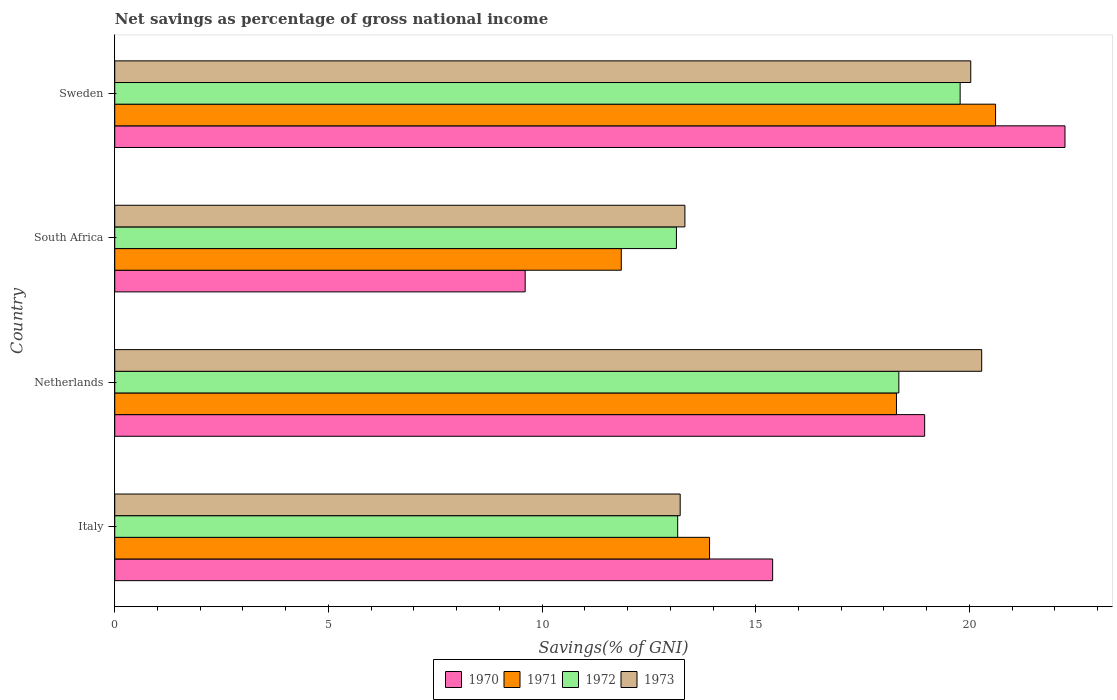How many different coloured bars are there?
Offer a very short reply. 4. Are the number of bars per tick equal to the number of legend labels?
Give a very brief answer. Yes. Are the number of bars on each tick of the Y-axis equal?
Offer a very short reply. Yes. How many bars are there on the 4th tick from the top?
Offer a terse response. 4. In how many cases, is the number of bars for a given country not equal to the number of legend labels?
Provide a short and direct response. 0. What is the total savings in 1972 in Netherlands?
Offer a terse response. 18.35. Across all countries, what is the maximum total savings in 1972?
Your answer should be very brief. 19.78. Across all countries, what is the minimum total savings in 1971?
Provide a succinct answer. 11.85. In which country was the total savings in 1973 maximum?
Make the answer very short. Netherlands. In which country was the total savings in 1973 minimum?
Ensure brevity in your answer.  Italy. What is the total total savings in 1971 in the graph?
Make the answer very short. 64.68. What is the difference between the total savings in 1973 in Netherlands and that in Sweden?
Offer a very short reply. 0.26. What is the difference between the total savings in 1970 in Italy and the total savings in 1971 in Sweden?
Offer a terse response. -5.22. What is the average total savings in 1972 per country?
Provide a succinct answer. 16.11. What is the difference between the total savings in 1971 and total savings in 1973 in Italy?
Offer a very short reply. 0.69. In how many countries, is the total savings in 1973 greater than 10 %?
Your response must be concise. 4. What is the ratio of the total savings in 1973 in Netherlands to that in South Africa?
Offer a very short reply. 1.52. Is the total savings in 1970 in Netherlands less than that in South Africa?
Make the answer very short. No. Is the difference between the total savings in 1971 in Netherlands and South Africa greater than the difference between the total savings in 1973 in Netherlands and South Africa?
Offer a very short reply. No. What is the difference between the highest and the second highest total savings in 1971?
Provide a succinct answer. 2.32. What is the difference between the highest and the lowest total savings in 1973?
Your response must be concise. 7.06. What does the 3rd bar from the bottom in Italy represents?
Keep it short and to the point. 1972. Are all the bars in the graph horizontal?
Provide a short and direct response. Yes. What is the difference between two consecutive major ticks on the X-axis?
Ensure brevity in your answer.  5. Are the values on the major ticks of X-axis written in scientific E-notation?
Your answer should be compact. No. Does the graph contain grids?
Provide a succinct answer. No. Where does the legend appear in the graph?
Your response must be concise. Bottom center. How many legend labels are there?
Give a very brief answer. 4. What is the title of the graph?
Your answer should be compact. Net savings as percentage of gross national income. Does "2011" appear as one of the legend labels in the graph?
Give a very brief answer. No. What is the label or title of the X-axis?
Give a very brief answer. Savings(% of GNI). What is the label or title of the Y-axis?
Your answer should be very brief. Country. What is the Savings(% of GNI) in 1970 in Italy?
Keep it short and to the point. 15.4. What is the Savings(% of GNI) in 1971 in Italy?
Offer a terse response. 13.92. What is the Savings(% of GNI) in 1972 in Italy?
Give a very brief answer. 13.17. What is the Savings(% of GNI) of 1973 in Italy?
Your answer should be compact. 13.23. What is the Savings(% of GNI) in 1970 in Netherlands?
Offer a very short reply. 18.95. What is the Savings(% of GNI) in 1971 in Netherlands?
Provide a succinct answer. 18.29. What is the Savings(% of GNI) of 1972 in Netherlands?
Ensure brevity in your answer.  18.35. What is the Savings(% of GNI) in 1973 in Netherlands?
Ensure brevity in your answer.  20.29. What is the Savings(% of GNI) of 1970 in South Africa?
Your answer should be very brief. 9.6. What is the Savings(% of GNI) in 1971 in South Africa?
Your answer should be compact. 11.85. What is the Savings(% of GNI) in 1972 in South Africa?
Give a very brief answer. 13.14. What is the Savings(% of GNI) in 1973 in South Africa?
Give a very brief answer. 13.34. What is the Savings(% of GNI) in 1970 in Sweden?
Your answer should be very brief. 22.24. What is the Savings(% of GNI) in 1971 in Sweden?
Your answer should be compact. 20.61. What is the Savings(% of GNI) of 1972 in Sweden?
Your answer should be very brief. 19.78. What is the Savings(% of GNI) of 1973 in Sweden?
Make the answer very short. 20.03. Across all countries, what is the maximum Savings(% of GNI) of 1970?
Your answer should be compact. 22.24. Across all countries, what is the maximum Savings(% of GNI) of 1971?
Ensure brevity in your answer.  20.61. Across all countries, what is the maximum Savings(% of GNI) in 1972?
Your answer should be compact. 19.78. Across all countries, what is the maximum Savings(% of GNI) in 1973?
Your answer should be very brief. 20.29. Across all countries, what is the minimum Savings(% of GNI) of 1970?
Offer a very short reply. 9.6. Across all countries, what is the minimum Savings(% of GNI) of 1971?
Offer a very short reply. 11.85. Across all countries, what is the minimum Savings(% of GNI) of 1972?
Offer a very short reply. 13.14. Across all countries, what is the minimum Savings(% of GNI) of 1973?
Provide a short and direct response. 13.23. What is the total Savings(% of GNI) in 1970 in the graph?
Your response must be concise. 66.19. What is the total Savings(% of GNI) in 1971 in the graph?
Give a very brief answer. 64.68. What is the total Savings(% of GNI) in 1972 in the graph?
Your answer should be very brief. 64.45. What is the total Savings(% of GNI) in 1973 in the graph?
Your answer should be compact. 66.89. What is the difference between the Savings(% of GNI) in 1970 in Italy and that in Netherlands?
Make the answer very short. -3.56. What is the difference between the Savings(% of GNI) in 1971 in Italy and that in Netherlands?
Your answer should be compact. -4.37. What is the difference between the Savings(% of GNI) in 1972 in Italy and that in Netherlands?
Provide a succinct answer. -5.18. What is the difference between the Savings(% of GNI) in 1973 in Italy and that in Netherlands?
Your answer should be very brief. -7.06. What is the difference between the Savings(% of GNI) in 1970 in Italy and that in South Africa?
Your answer should be very brief. 5.79. What is the difference between the Savings(% of GNI) in 1971 in Italy and that in South Africa?
Your answer should be compact. 2.07. What is the difference between the Savings(% of GNI) in 1972 in Italy and that in South Africa?
Provide a succinct answer. 0.03. What is the difference between the Savings(% of GNI) of 1973 in Italy and that in South Africa?
Your answer should be compact. -0.11. What is the difference between the Savings(% of GNI) of 1970 in Italy and that in Sweden?
Ensure brevity in your answer.  -6.84. What is the difference between the Savings(% of GNI) in 1971 in Italy and that in Sweden?
Make the answer very short. -6.69. What is the difference between the Savings(% of GNI) in 1972 in Italy and that in Sweden?
Make the answer very short. -6.61. What is the difference between the Savings(% of GNI) of 1973 in Italy and that in Sweden?
Your response must be concise. -6.8. What is the difference between the Savings(% of GNI) of 1970 in Netherlands and that in South Africa?
Provide a short and direct response. 9.35. What is the difference between the Savings(% of GNI) in 1971 in Netherlands and that in South Africa?
Give a very brief answer. 6.44. What is the difference between the Savings(% of GNI) in 1972 in Netherlands and that in South Africa?
Offer a very short reply. 5.21. What is the difference between the Savings(% of GNI) in 1973 in Netherlands and that in South Africa?
Ensure brevity in your answer.  6.95. What is the difference between the Savings(% of GNI) of 1970 in Netherlands and that in Sweden?
Your answer should be compact. -3.28. What is the difference between the Savings(% of GNI) in 1971 in Netherlands and that in Sweden?
Ensure brevity in your answer.  -2.32. What is the difference between the Savings(% of GNI) in 1972 in Netherlands and that in Sweden?
Keep it short and to the point. -1.43. What is the difference between the Savings(% of GNI) in 1973 in Netherlands and that in Sweden?
Provide a short and direct response. 0.26. What is the difference between the Savings(% of GNI) of 1970 in South Africa and that in Sweden?
Give a very brief answer. -12.63. What is the difference between the Savings(% of GNI) in 1971 in South Africa and that in Sweden?
Provide a succinct answer. -8.76. What is the difference between the Savings(% of GNI) in 1972 in South Africa and that in Sweden?
Offer a very short reply. -6.64. What is the difference between the Savings(% of GNI) of 1973 in South Africa and that in Sweden?
Give a very brief answer. -6.69. What is the difference between the Savings(% of GNI) of 1970 in Italy and the Savings(% of GNI) of 1971 in Netherlands?
Your response must be concise. -2.9. What is the difference between the Savings(% of GNI) of 1970 in Italy and the Savings(% of GNI) of 1972 in Netherlands?
Give a very brief answer. -2.95. What is the difference between the Savings(% of GNI) in 1970 in Italy and the Savings(% of GNI) in 1973 in Netherlands?
Provide a short and direct response. -4.89. What is the difference between the Savings(% of GNI) of 1971 in Italy and the Savings(% of GNI) of 1972 in Netherlands?
Your answer should be very brief. -4.43. What is the difference between the Savings(% of GNI) in 1971 in Italy and the Savings(% of GNI) in 1973 in Netherlands?
Keep it short and to the point. -6.37. What is the difference between the Savings(% of GNI) of 1972 in Italy and the Savings(% of GNI) of 1973 in Netherlands?
Your answer should be compact. -7.11. What is the difference between the Savings(% of GNI) of 1970 in Italy and the Savings(% of GNI) of 1971 in South Africa?
Your answer should be very brief. 3.54. What is the difference between the Savings(% of GNI) in 1970 in Italy and the Savings(% of GNI) in 1972 in South Africa?
Provide a short and direct response. 2.25. What is the difference between the Savings(% of GNI) of 1970 in Italy and the Savings(% of GNI) of 1973 in South Africa?
Keep it short and to the point. 2.05. What is the difference between the Savings(% of GNI) in 1971 in Italy and the Savings(% of GNI) in 1972 in South Africa?
Keep it short and to the point. 0.78. What is the difference between the Savings(% of GNI) of 1971 in Italy and the Savings(% of GNI) of 1973 in South Africa?
Your response must be concise. 0.58. What is the difference between the Savings(% of GNI) of 1972 in Italy and the Savings(% of GNI) of 1973 in South Africa?
Make the answer very short. -0.17. What is the difference between the Savings(% of GNI) in 1970 in Italy and the Savings(% of GNI) in 1971 in Sweden?
Give a very brief answer. -5.22. What is the difference between the Savings(% of GNI) of 1970 in Italy and the Savings(% of GNI) of 1972 in Sweden?
Provide a short and direct response. -4.39. What is the difference between the Savings(% of GNI) in 1970 in Italy and the Savings(% of GNI) in 1973 in Sweden?
Offer a terse response. -4.64. What is the difference between the Savings(% of GNI) in 1971 in Italy and the Savings(% of GNI) in 1972 in Sweden?
Your response must be concise. -5.86. What is the difference between the Savings(% of GNI) in 1971 in Italy and the Savings(% of GNI) in 1973 in Sweden?
Provide a short and direct response. -6.11. What is the difference between the Savings(% of GNI) of 1972 in Italy and the Savings(% of GNI) of 1973 in Sweden?
Your answer should be very brief. -6.86. What is the difference between the Savings(% of GNI) of 1970 in Netherlands and the Savings(% of GNI) of 1971 in South Africa?
Ensure brevity in your answer.  7.1. What is the difference between the Savings(% of GNI) in 1970 in Netherlands and the Savings(% of GNI) in 1972 in South Africa?
Your answer should be very brief. 5.81. What is the difference between the Savings(% of GNI) of 1970 in Netherlands and the Savings(% of GNI) of 1973 in South Africa?
Keep it short and to the point. 5.61. What is the difference between the Savings(% of GNI) in 1971 in Netherlands and the Savings(% of GNI) in 1972 in South Africa?
Offer a terse response. 5.15. What is the difference between the Savings(% of GNI) of 1971 in Netherlands and the Savings(% of GNI) of 1973 in South Africa?
Offer a very short reply. 4.95. What is the difference between the Savings(% of GNI) of 1972 in Netherlands and the Savings(% of GNI) of 1973 in South Africa?
Keep it short and to the point. 5.01. What is the difference between the Savings(% of GNI) of 1970 in Netherlands and the Savings(% of GNI) of 1971 in Sweden?
Provide a succinct answer. -1.66. What is the difference between the Savings(% of GNI) of 1970 in Netherlands and the Savings(% of GNI) of 1972 in Sweden?
Offer a terse response. -0.83. What is the difference between the Savings(% of GNI) in 1970 in Netherlands and the Savings(% of GNI) in 1973 in Sweden?
Keep it short and to the point. -1.08. What is the difference between the Savings(% of GNI) of 1971 in Netherlands and the Savings(% of GNI) of 1972 in Sweden?
Ensure brevity in your answer.  -1.49. What is the difference between the Savings(% of GNI) in 1971 in Netherlands and the Savings(% of GNI) in 1973 in Sweden?
Make the answer very short. -1.74. What is the difference between the Savings(% of GNI) of 1972 in Netherlands and the Savings(% of GNI) of 1973 in Sweden?
Offer a very short reply. -1.68. What is the difference between the Savings(% of GNI) of 1970 in South Africa and the Savings(% of GNI) of 1971 in Sweden?
Make the answer very short. -11.01. What is the difference between the Savings(% of GNI) of 1970 in South Africa and the Savings(% of GNI) of 1972 in Sweden?
Your answer should be compact. -10.18. What is the difference between the Savings(% of GNI) in 1970 in South Africa and the Savings(% of GNI) in 1973 in Sweden?
Your response must be concise. -10.43. What is the difference between the Savings(% of GNI) of 1971 in South Africa and the Savings(% of GNI) of 1972 in Sweden?
Provide a short and direct response. -7.93. What is the difference between the Savings(% of GNI) of 1971 in South Africa and the Savings(% of GNI) of 1973 in Sweden?
Provide a succinct answer. -8.18. What is the difference between the Savings(% of GNI) of 1972 in South Africa and the Savings(% of GNI) of 1973 in Sweden?
Offer a very short reply. -6.89. What is the average Savings(% of GNI) of 1970 per country?
Your response must be concise. 16.55. What is the average Savings(% of GNI) of 1971 per country?
Your response must be concise. 16.17. What is the average Savings(% of GNI) in 1972 per country?
Your answer should be compact. 16.11. What is the average Savings(% of GNI) in 1973 per country?
Give a very brief answer. 16.72. What is the difference between the Savings(% of GNI) in 1970 and Savings(% of GNI) in 1971 in Italy?
Offer a very short reply. 1.48. What is the difference between the Savings(% of GNI) of 1970 and Savings(% of GNI) of 1972 in Italy?
Offer a terse response. 2.22. What is the difference between the Savings(% of GNI) of 1970 and Savings(% of GNI) of 1973 in Italy?
Keep it short and to the point. 2.16. What is the difference between the Savings(% of GNI) of 1971 and Savings(% of GNI) of 1972 in Italy?
Keep it short and to the point. 0.75. What is the difference between the Savings(% of GNI) in 1971 and Savings(% of GNI) in 1973 in Italy?
Your response must be concise. 0.69. What is the difference between the Savings(% of GNI) in 1972 and Savings(% of GNI) in 1973 in Italy?
Your answer should be compact. -0.06. What is the difference between the Savings(% of GNI) in 1970 and Savings(% of GNI) in 1971 in Netherlands?
Ensure brevity in your answer.  0.66. What is the difference between the Savings(% of GNI) in 1970 and Savings(% of GNI) in 1972 in Netherlands?
Keep it short and to the point. 0.6. What is the difference between the Savings(% of GNI) in 1970 and Savings(% of GNI) in 1973 in Netherlands?
Keep it short and to the point. -1.33. What is the difference between the Savings(% of GNI) in 1971 and Savings(% of GNI) in 1972 in Netherlands?
Make the answer very short. -0.06. What is the difference between the Savings(% of GNI) of 1971 and Savings(% of GNI) of 1973 in Netherlands?
Provide a short and direct response. -1.99. What is the difference between the Savings(% of GNI) of 1972 and Savings(% of GNI) of 1973 in Netherlands?
Your answer should be compact. -1.94. What is the difference between the Savings(% of GNI) of 1970 and Savings(% of GNI) of 1971 in South Africa?
Provide a succinct answer. -2.25. What is the difference between the Savings(% of GNI) in 1970 and Savings(% of GNI) in 1972 in South Africa?
Offer a very short reply. -3.54. What is the difference between the Savings(% of GNI) of 1970 and Savings(% of GNI) of 1973 in South Africa?
Your answer should be very brief. -3.74. What is the difference between the Savings(% of GNI) of 1971 and Savings(% of GNI) of 1972 in South Africa?
Your answer should be very brief. -1.29. What is the difference between the Savings(% of GNI) of 1971 and Savings(% of GNI) of 1973 in South Africa?
Provide a succinct answer. -1.49. What is the difference between the Savings(% of GNI) of 1972 and Savings(% of GNI) of 1973 in South Africa?
Ensure brevity in your answer.  -0.2. What is the difference between the Savings(% of GNI) in 1970 and Savings(% of GNI) in 1971 in Sweden?
Keep it short and to the point. 1.62. What is the difference between the Savings(% of GNI) in 1970 and Savings(% of GNI) in 1972 in Sweden?
Make the answer very short. 2.45. What is the difference between the Savings(% of GNI) of 1970 and Savings(% of GNI) of 1973 in Sweden?
Offer a terse response. 2.21. What is the difference between the Savings(% of GNI) of 1971 and Savings(% of GNI) of 1972 in Sweden?
Your answer should be compact. 0.83. What is the difference between the Savings(% of GNI) of 1971 and Savings(% of GNI) of 1973 in Sweden?
Ensure brevity in your answer.  0.58. What is the difference between the Savings(% of GNI) in 1972 and Savings(% of GNI) in 1973 in Sweden?
Ensure brevity in your answer.  -0.25. What is the ratio of the Savings(% of GNI) of 1970 in Italy to that in Netherlands?
Provide a short and direct response. 0.81. What is the ratio of the Savings(% of GNI) in 1971 in Italy to that in Netherlands?
Make the answer very short. 0.76. What is the ratio of the Savings(% of GNI) of 1972 in Italy to that in Netherlands?
Keep it short and to the point. 0.72. What is the ratio of the Savings(% of GNI) of 1973 in Italy to that in Netherlands?
Provide a short and direct response. 0.65. What is the ratio of the Savings(% of GNI) in 1970 in Italy to that in South Africa?
Keep it short and to the point. 1.6. What is the ratio of the Savings(% of GNI) in 1971 in Italy to that in South Africa?
Offer a terse response. 1.17. What is the ratio of the Savings(% of GNI) of 1973 in Italy to that in South Africa?
Keep it short and to the point. 0.99. What is the ratio of the Savings(% of GNI) in 1970 in Italy to that in Sweden?
Your answer should be compact. 0.69. What is the ratio of the Savings(% of GNI) of 1971 in Italy to that in Sweden?
Offer a very short reply. 0.68. What is the ratio of the Savings(% of GNI) of 1972 in Italy to that in Sweden?
Provide a short and direct response. 0.67. What is the ratio of the Savings(% of GNI) in 1973 in Italy to that in Sweden?
Offer a very short reply. 0.66. What is the ratio of the Savings(% of GNI) of 1970 in Netherlands to that in South Africa?
Give a very brief answer. 1.97. What is the ratio of the Savings(% of GNI) of 1971 in Netherlands to that in South Africa?
Provide a succinct answer. 1.54. What is the ratio of the Savings(% of GNI) of 1972 in Netherlands to that in South Africa?
Your response must be concise. 1.4. What is the ratio of the Savings(% of GNI) of 1973 in Netherlands to that in South Africa?
Ensure brevity in your answer.  1.52. What is the ratio of the Savings(% of GNI) of 1970 in Netherlands to that in Sweden?
Offer a very short reply. 0.85. What is the ratio of the Savings(% of GNI) of 1971 in Netherlands to that in Sweden?
Provide a succinct answer. 0.89. What is the ratio of the Savings(% of GNI) of 1972 in Netherlands to that in Sweden?
Your answer should be compact. 0.93. What is the ratio of the Savings(% of GNI) of 1973 in Netherlands to that in Sweden?
Make the answer very short. 1.01. What is the ratio of the Savings(% of GNI) of 1970 in South Africa to that in Sweden?
Offer a very short reply. 0.43. What is the ratio of the Savings(% of GNI) in 1971 in South Africa to that in Sweden?
Offer a very short reply. 0.58. What is the ratio of the Savings(% of GNI) in 1972 in South Africa to that in Sweden?
Make the answer very short. 0.66. What is the ratio of the Savings(% of GNI) of 1973 in South Africa to that in Sweden?
Your answer should be compact. 0.67. What is the difference between the highest and the second highest Savings(% of GNI) of 1970?
Provide a succinct answer. 3.28. What is the difference between the highest and the second highest Savings(% of GNI) in 1971?
Ensure brevity in your answer.  2.32. What is the difference between the highest and the second highest Savings(% of GNI) in 1972?
Provide a short and direct response. 1.43. What is the difference between the highest and the second highest Savings(% of GNI) of 1973?
Give a very brief answer. 0.26. What is the difference between the highest and the lowest Savings(% of GNI) of 1970?
Make the answer very short. 12.63. What is the difference between the highest and the lowest Savings(% of GNI) of 1971?
Your answer should be compact. 8.76. What is the difference between the highest and the lowest Savings(% of GNI) of 1972?
Make the answer very short. 6.64. What is the difference between the highest and the lowest Savings(% of GNI) in 1973?
Your answer should be compact. 7.06. 